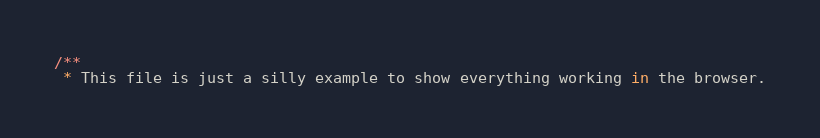Convert code to text. <code><loc_0><loc_0><loc_500><loc_500><_JavaScript_>/**
 * This file is just a silly example to show everything working in the browser.</code> 